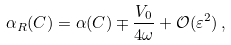<formula> <loc_0><loc_0><loc_500><loc_500>\alpha _ { R } ( C ) = \alpha ( C ) \mp \frac { V _ { 0 } } { 4 \omega } + \mathcal { O } ( \varepsilon ^ { 2 } ) \, ,</formula> 